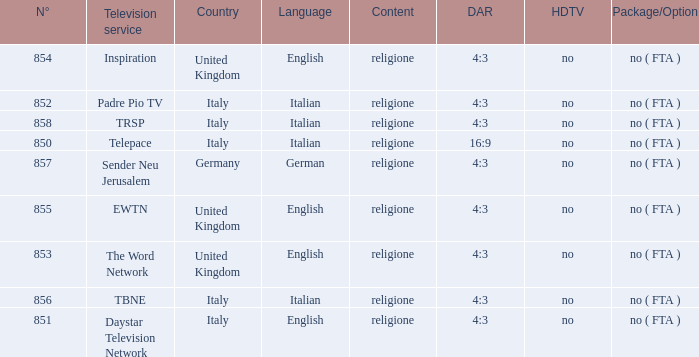How many dar are in germany? 4:3. 